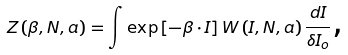<formula> <loc_0><loc_0><loc_500><loc_500>Z \left ( \beta , N , a \right ) = \int \exp \left [ - \beta \cdot I \right ] W \left ( I , N , a \right ) \frac { d I } { \delta I _ { o } } \text {,}</formula> 